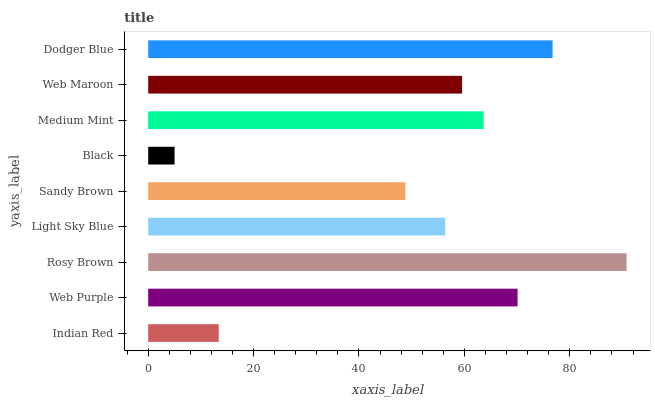Is Black the minimum?
Answer yes or no. Yes. Is Rosy Brown the maximum?
Answer yes or no. Yes. Is Web Purple the minimum?
Answer yes or no. No. Is Web Purple the maximum?
Answer yes or no. No. Is Web Purple greater than Indian Red?
Answer yes or no. Yes. Is Indian Red less than Web Purple?
Answer yes or no. Yes. Is Indian Red greater than Web Purple?
Answer yes or no. No. Is Web Purple less than Indian Red?
Answer yes or no. No. Is Web Maroon the high median?
Answer yes or no. Yes. Is Web Maroon the low median?
Answer yes or no. Yes. Is Light Sky Blue the high median?
Answer yes or no. No. Is Medium Mint the low median?
Answer yes or no. No. 